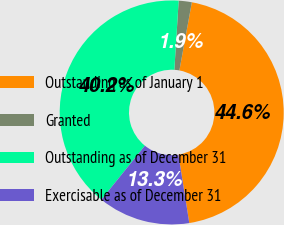Convert chart. <chart><loc_0><loc_0><loc_500><loc_500><pie_chart><fcel>Outstanding as of January 1<fcel>Granted<fcel>Outstanding as of December 31<fcel>Exercisable as of December 31<nl><fcel>44.61%<fcel>1.89%<fcel>40.19%<fcel>13.31%<nl></chart> 